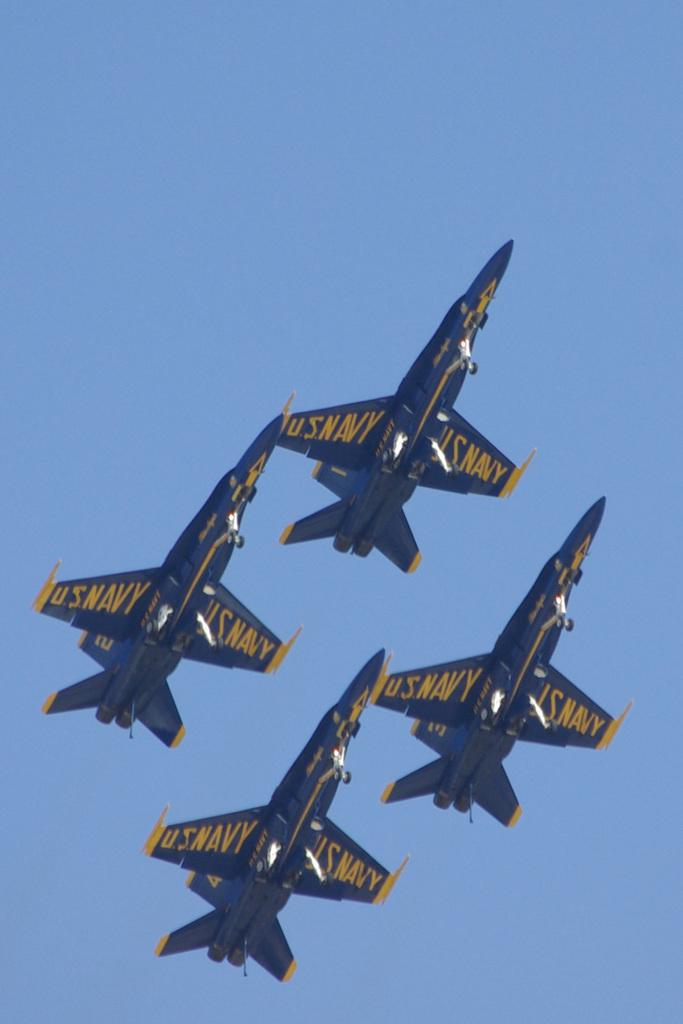<image>
Share a concise interpretation of the image provided. Four yellow and blue airplanes with U.S Navy signs on the wings. 